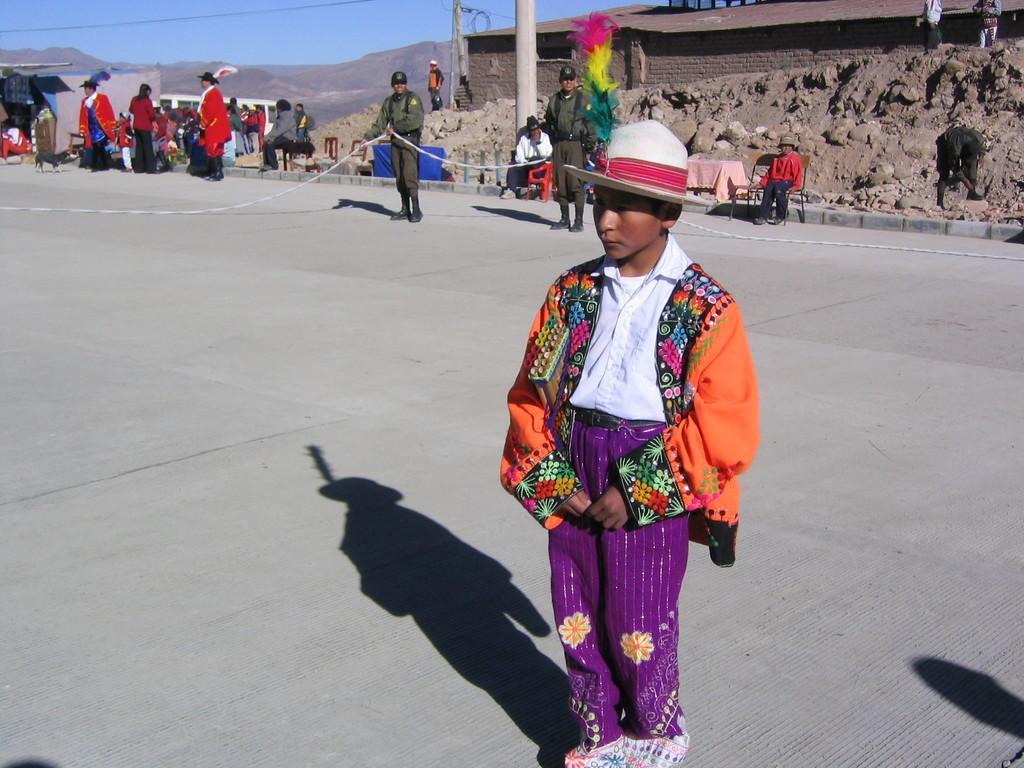Please provide a concise description of this image. In the center of the image we can see a boy is standing and wearing costume, hat. In the background of the image we can see the mountains, houses, poles, wires, chairs, tablecloths, store, heap of sand, roof and a group of people. We can see two mens are wearing a uniform and holding a rope. In the top left corner we can see two mens are standing and wearing costume. At the bottom of the image we can see the road. At the top of the image we can see the sky. 